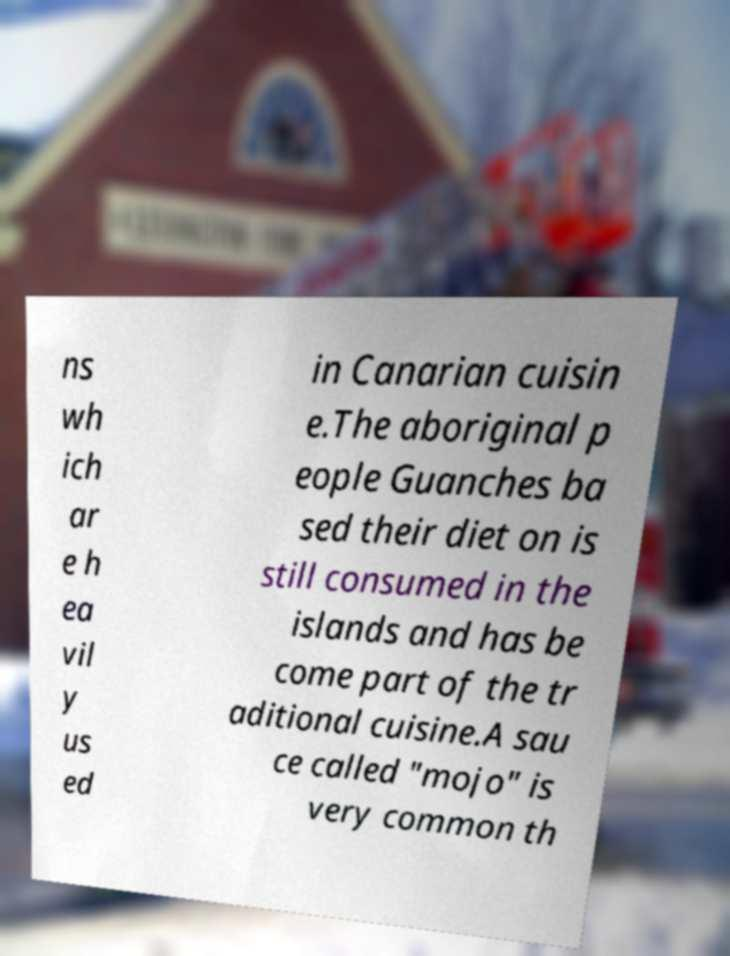For documentation purposes, I need the text within this image transcribed. Could you provide that? ns wh ich ar e h ea vil y us ed in Canarian cuisin e.The aboriginal p eople Guanches ba sed their diet on is still consumed in the islands and has be come part of the tr aditional cuisine.A sau ce called "mojo" is very common th 